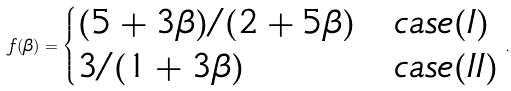Convert formula to latex. <formula><loc_0><loc_0><loc_500><loc_500>f ( \beta ) = \begin{cases} ( 5 + 3 \beta ) / ( 2 + 5 \beta ) & c a s e ( I ) \\ 3 / ( 1 + 3 \beta ) & c a s e ( I I ) \end{cases} .</formula> 